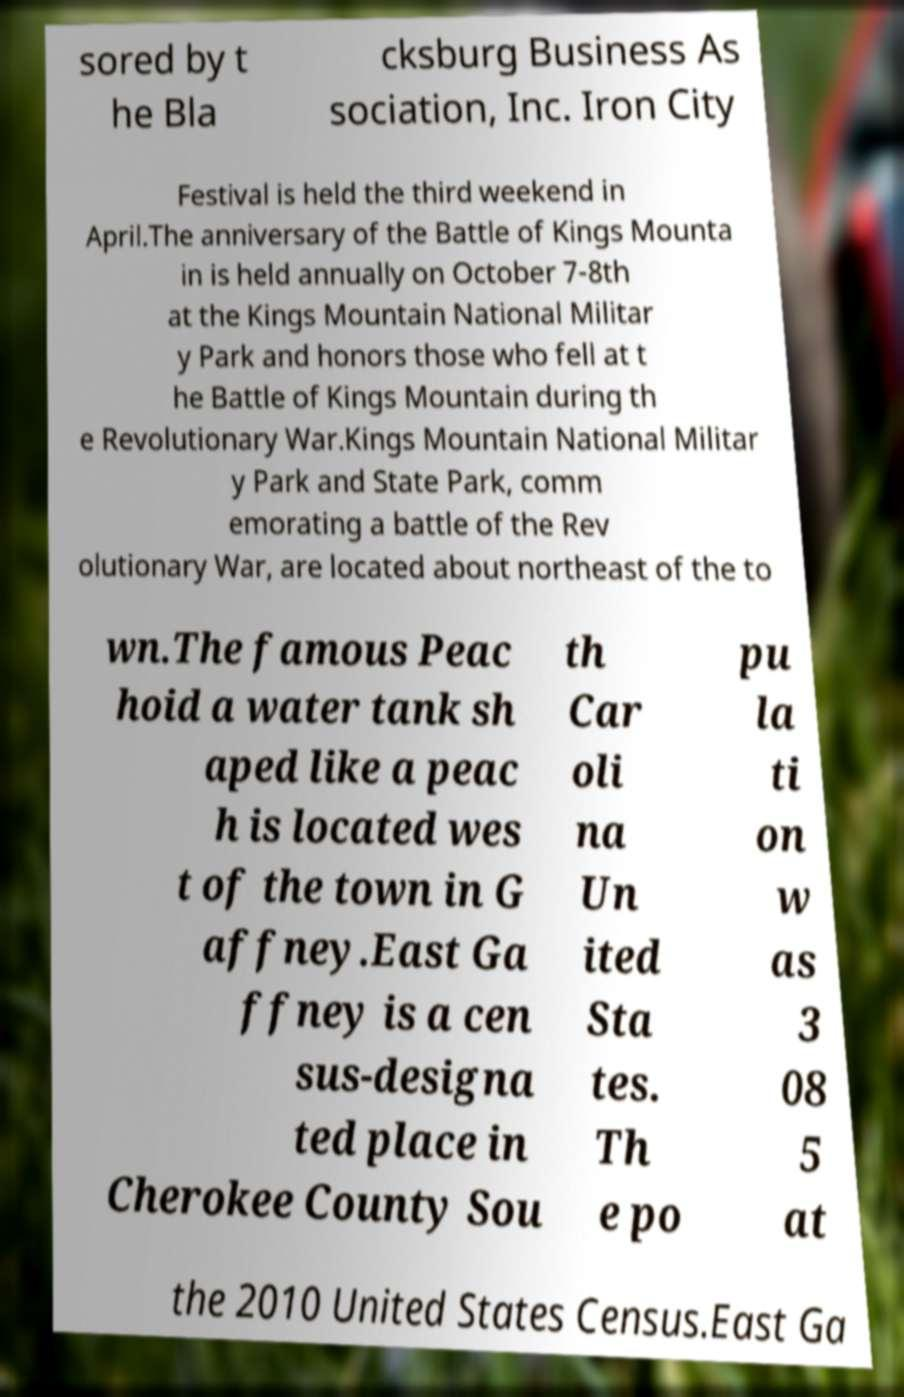I need the written content from this picture converted into text. Can you do that? sored by t he Bla cksburg Business As sociation, Inc. Iron City Festival is held the third weekend in April.The anniversary of the Battle of Kings Mounta in is held annually on October 7-8th at the Kings Mountain National Militar y Park and honors those who fell at t he Battle of Kings Mountain during th e Revolutionary War.Kings Mountain National Militar y Park and State Park, comm emorating a battle of the Rev olutionary War, are located about northeast of the to wn.The famous Peac hoid a water tank sh aped like a peac h is located wes t of the town in G affney.East Ga ffney is a cen sus-designa ted place in Cherokee County Sou th Car oli na Un ited Sta tes. Th e po pu la ti on w as 3 08 5 at the 2010 United States Census.East Ga 